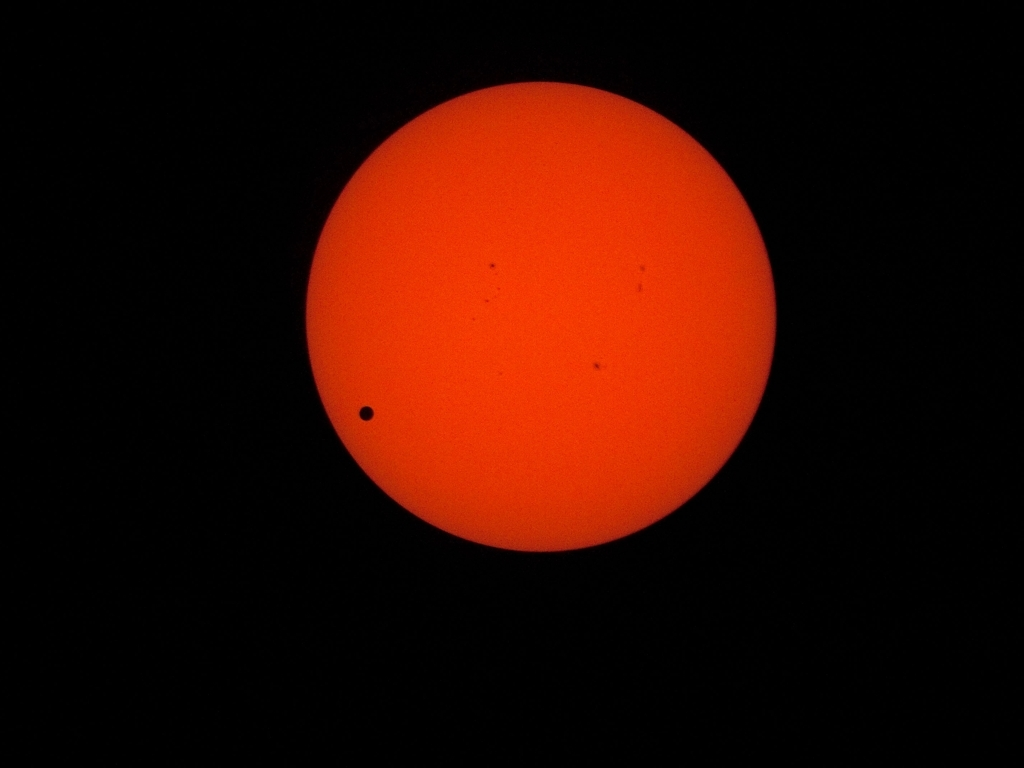What scientific significance do such transit events hold? Transit events have both historical and contemporary scientific significance. Historically, they've been used to calculate the size of the solar system, particularly the distance from the Earth to the sun, known as an astronomical unit. In modern times, these events generate interest in astronomy, providing opportunities to study the atmosphere of the transiting body, as it is backlit by the sun. Such observations can contribute to understanding the composition and dynamics of the planet's atmosphere. Additionally, by using similar transit detection methods, astronomers can discover and study planets outside our solar system, known as exoplanets. 